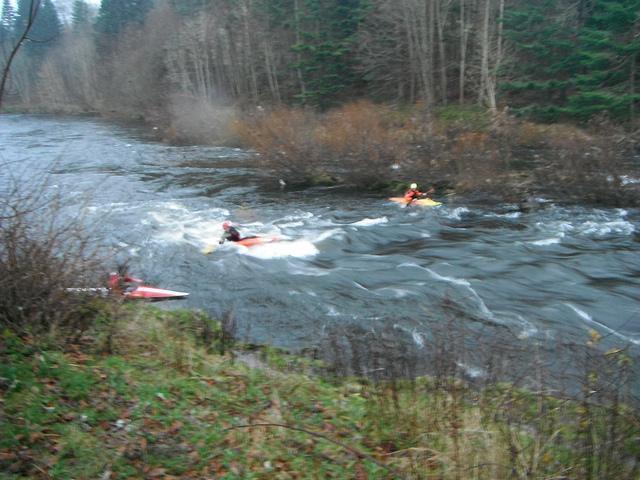Which direction are kayakers facing?
From the following set of four choices, select the accurate answer to respond to the question.
Options: Upside down, down stream, bank wards, up river. Up river. 